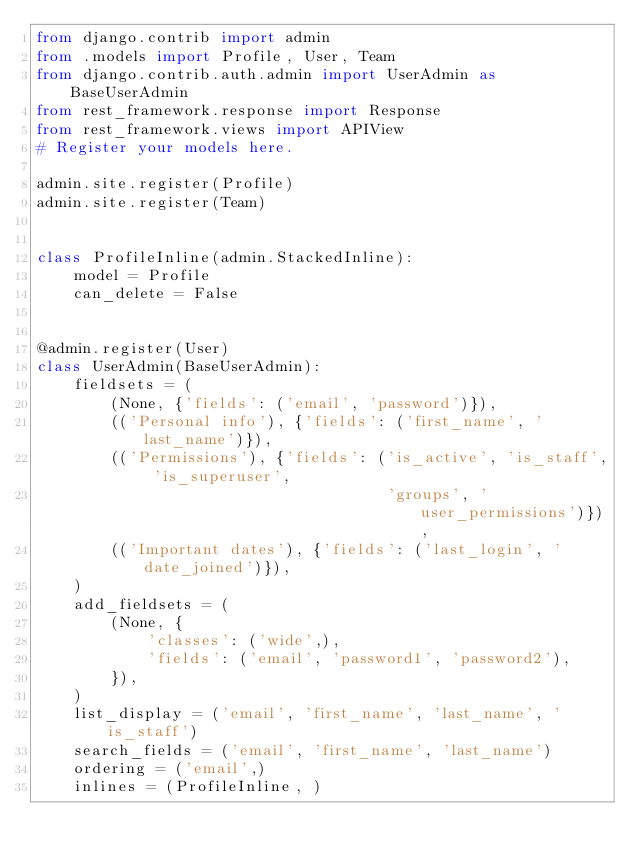Convert code to text. <code><loc_0><loc_0><loc_500><loc_500><_Python_>from django.contrib import admin
from .models import Profile, User, Team
from django.contrib.auth.admin import UserAdmin as BaseUserAdmin
from rest_framework.response import Response
from rest_framework.views import APIView
# Register your models here.

admin.site.register(Profile)
admin.site.register(Team)


class ProfileInline(admin.StackedInline):
    model = Profile
    can_delete = False


@admin.register(User)
class UserAdmin(BaseUserAdmin):
    fieldsets = (
        (None, {'fields': ('email', 'password')}),
        (('Personal info'), {'fields': ('first_name', 'last_name')}),
        (('Permissions'), {'fields': ('is_active', 'is_staff', 'is_superuser',
                                      'groups', 'user_permissions')}),
        (('Important dates'), {'fields': ('last_login', 'date_joined')}),
    )
    add_fieldsets = (
        (None, {
            'classes': ('wide',),
            'fields': ('email', 'password1', 'password2'),
        }),
    )
    list_display = ('email', 'first_name', 'last_name', 'is_staff')
    search_fields = ('email', 'first_name', 'last_name')
    ordering = ('email',)
    inlines = (ProfileInline, )
</code> 